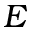Convert formula to latex. <formula><loc_0><loc_0><loc_500><loc_500>E</formula> 